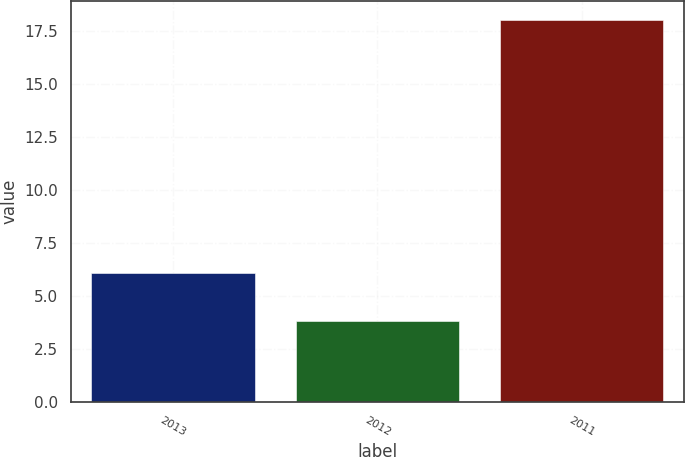Convert chart to OTSL. <chart><loc_0><loc_0><loc_500><loc_500><bar_chart><fcel>2013<fcel>2012<fcel>2011<nl><fcel>6.1<fcel>3.8<fcel>18<nl></chart> 